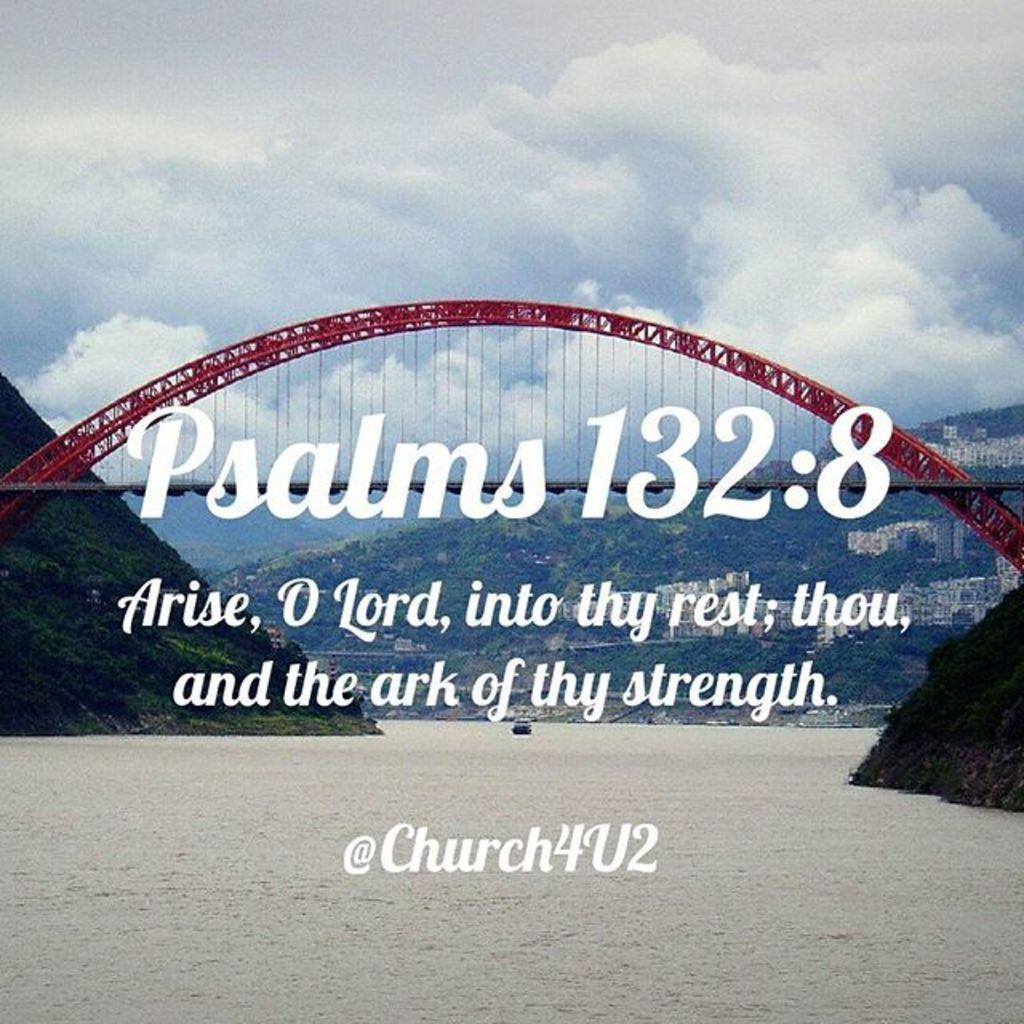Provide a one-sentence caption for the provided image. A PICTURE OF A RED BRIDGE OVER WATER WITH A PSALM SAYING. 